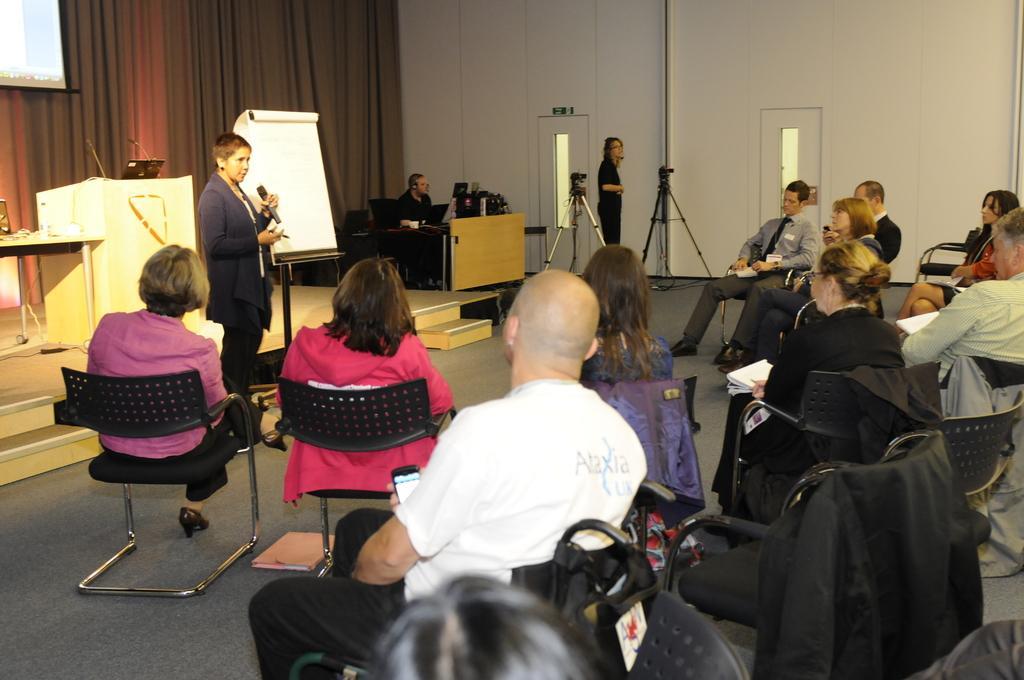Can you describe this image briefly? so many people sitting on a chair behind there is a woman speaking on the microphone and two cameras on the stand 